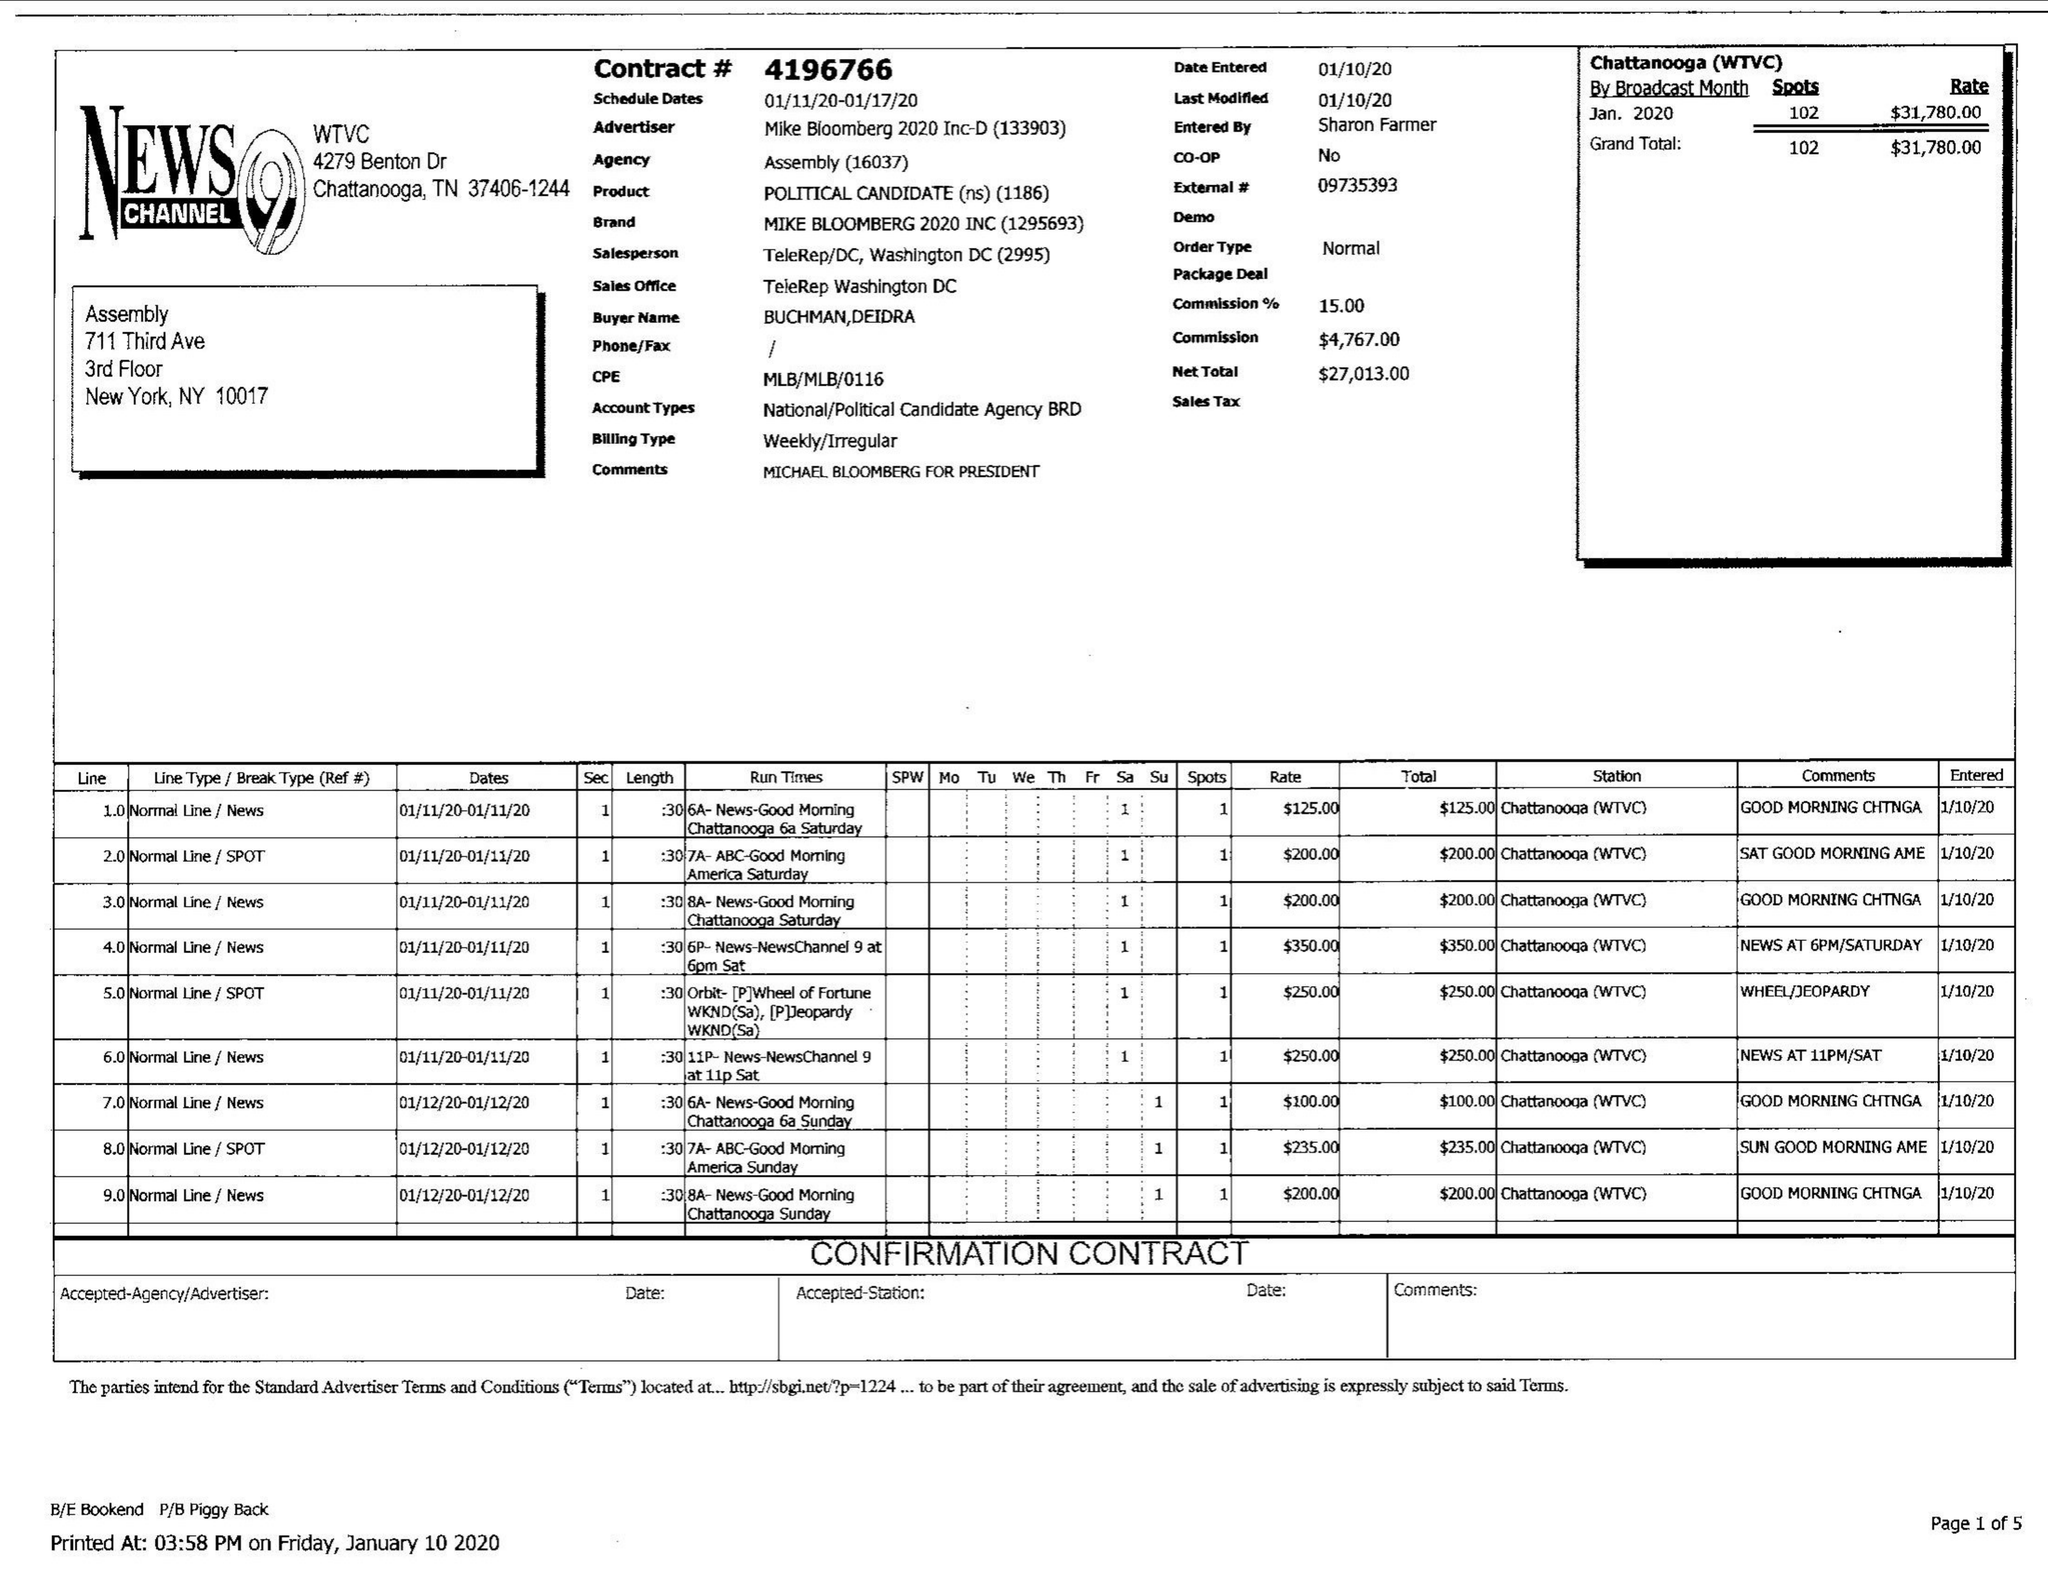What is the value for the flight_from?
Answer the question using a single word or phrase. 01/11/20 